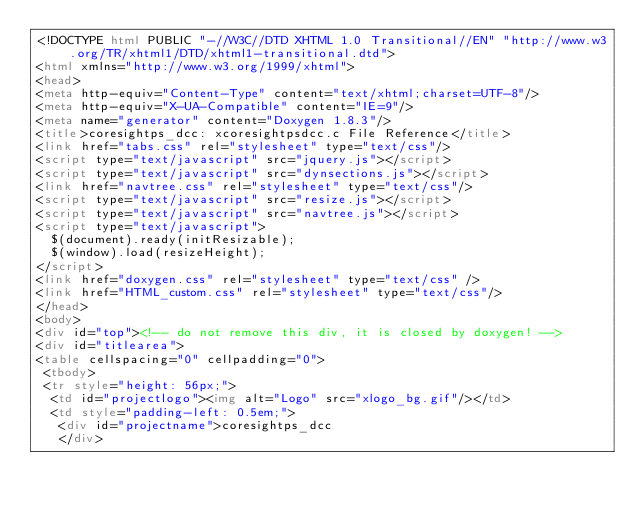<code> <loc_0><loc_0><loc_500><loc_500><_HTML_><!DOCTYPE html PUBLIC "-//W3C//DTD XHTML 1.0 Transitional//EN" "http://www.w3.org/TR/xhtml1/DTD/xhtml1-transitional.dtd">
<html xmlns="http://www.w3.org/1999/xhtml">
<head>
<meta http-equiv="Content-Type" content="text/xhtml;charset=UTF-8"/>
<meta http-equiv="X-UA-Compatible" content="IE=9"/>
<meta name="generator" content="Doxygen 1.8.3"/>
<title>coresightps_dcc: xcoresightpsdcc.c File Reference</title>
<link href="tabs.css" rel="stylesheet" type="text/css"/>
<script type="text/javascript" src="jquery.js"></script>
<script type="text/javascript" src="dynsections.js"></script>
<link href="navtree.css" rel="stylesheet" type="text/css"/>
<script type="text/javascript" src="resize.js"></script>
<script type="text/javascript" src="navtree.js"></script>
<script type="text/javascript">
  $(document).ready(initResizable);
  $(window).load(resizeHeight);
</script>
<link href="doxygen.css" rel="stylesheet" type="text/css" />
<link href="HTML_custom.css" rel="stylesheet" type="text/css"/>
</head>
<body>
<div id="top"><!-- do not remove this div, it is closed by doxygen! -->
<div id="titlearea">
<table cellspacing="0" cellpadding="0">
 <tbody>
 <tr style="height: 56px;">
  <td id="projectlogo"><img alt="Logo" src="xlogo_bg.gif"/></td>
  <td style="padding-left: 0.5em;">
   <div id="projectname">coresightps_dcc
   </div></code> 